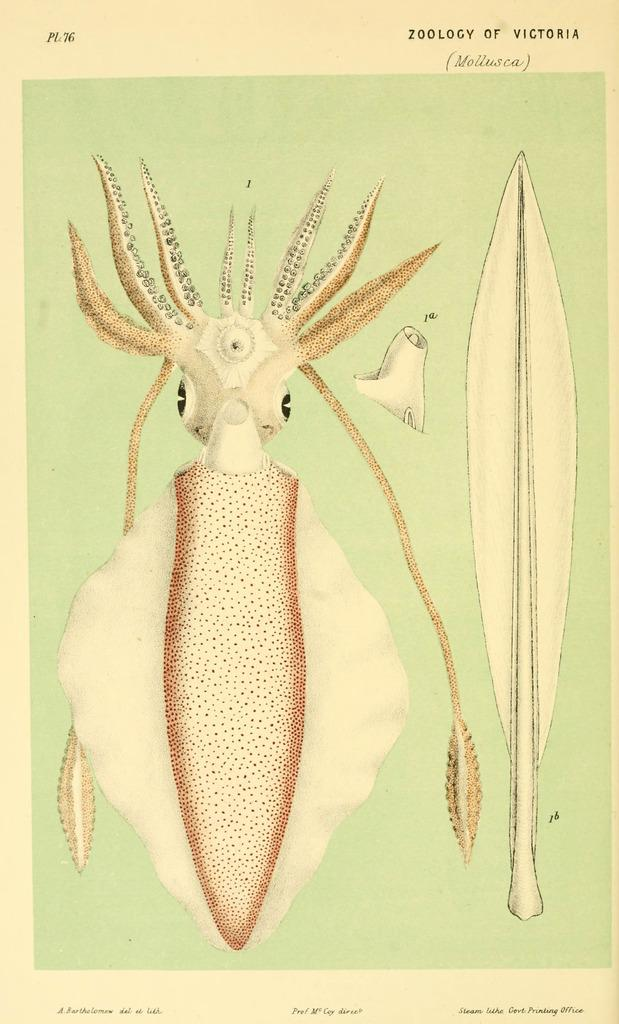What is the main subject of the image? There is a picture in the image. What is depicted in the picture? The picture contains a squid. What type of play is the squid participating in the image? There is no play or any indication of the squid's participation in a play in the image. 